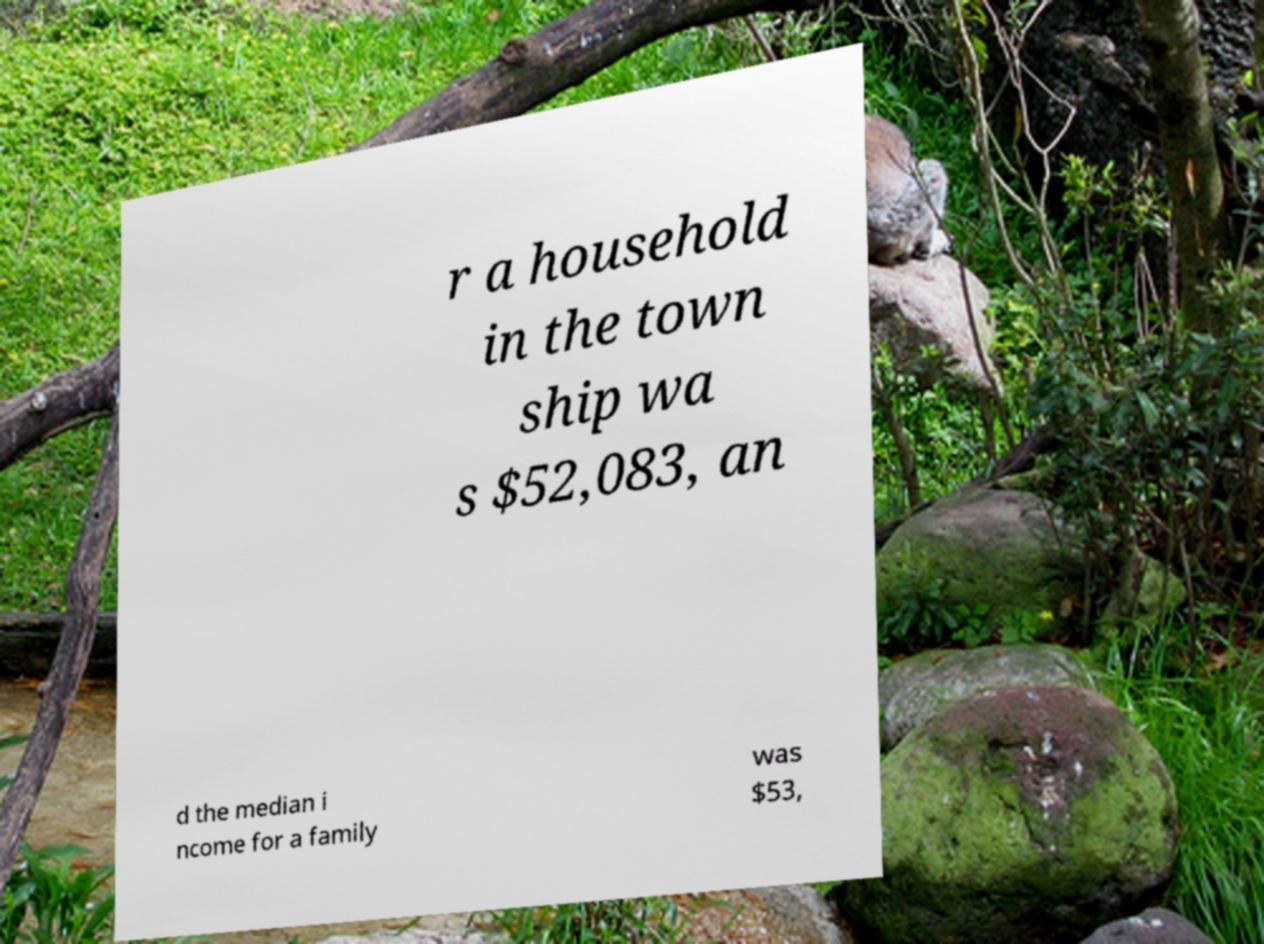Could you assist in decoding the text presented in this image and type it out clearly? r a household in the town ship wa s $52,083, an d the median i ncome for a family was $53, 